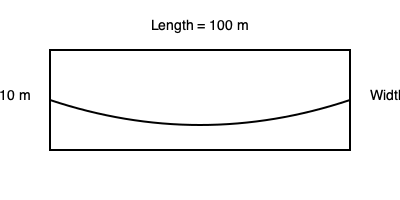A submarine has a cylindrical hull with hemispherical ends. Its length is 100 meters, height is 10 meters, and width is 8 meters. Calculate the submarine's displacement (volume of water displaced) in cubic meters. Use $\pi = 3.14$ for your calculations. To calculate the submarine's displacement, we need to find its volume. We can break this down into steps:

1. Calculate the volume of the cylindrical part:
   $V_{cylinder} = \pi r^2 h$
   where $r$ is the radius (half the width) and $h$ is the length of the cylinder.
   $r = 8/2 = 4$ meters
   $h = 100 - 10 = 90$ meters (subtracting the length of the hemispherical ends)
   $V_{cylinder} = 3.14 \times 4^2 \times 90 = 4521.6$ m³

2. Calculate the volume of the two hemispherical ends:
   $V_{hemisphere} = \frac{2}{3}\pi r^3$
   $V_{hemispheres} = 2 \times \frac{2}{3} \times 3.14 \times 4^3 = 267.95$ m³

3. Sum up the volumes:
   $V_{total} = V_{cylinder} + V_{hemispheres}$
   $V_{total} = 4521.6 + 267.95 = 4789.55$ m³

The displacement of the submarine is equal to its volume, which is approximately 4789.55 cubic meters.
Answer: 4789.55 m³ 